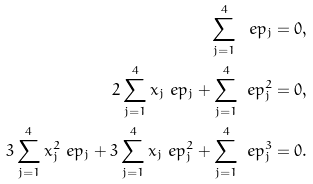Convert formula to latex. <formula><loc_0><loc_0><loc_500><loc_500>\sum _ { j = 1 } ^ { 4 } \ e p _ { j } = 0 , \\ 2 \sum _ { j = 1 } ^ { 4 } x _ { j } \ e p _ { j } + \sum _ { j = 1 } ^ { 4 } \ e p _ { j } ^ { 2 } = 0 , \\ 3 \sum _ { j = 1 } ^ { 4 } x _ { j } ^ { 2 } \ e p _ { j } + 3 \sum _ { j = 1 } ^ { 4 } x _ { j } \ e p _ { j } ^ { 2 } + \sum _ { j = 1 } ^ { 4 } \ e p _ { j } ^ { 3 } = 0 .</formula> 